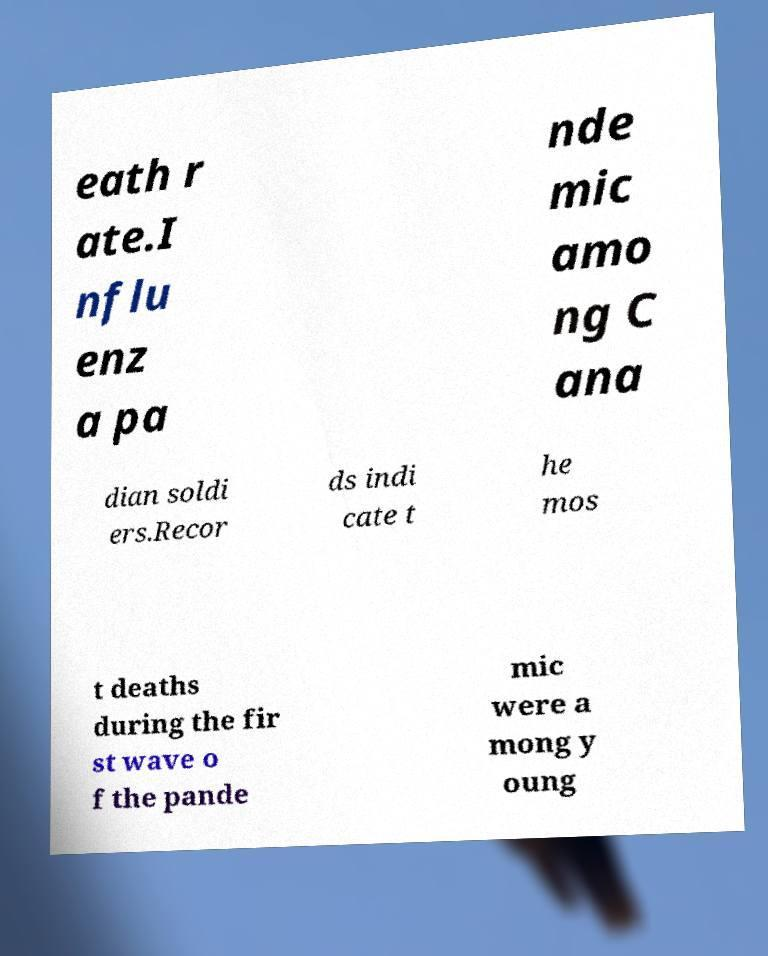What messages or text are displayed in this image? I need them in a readable, typed format. eath r ate.I nflu enz a pa nde mic amo ng C ana dian soldi ers.Recor ds indi cate t he mos t deaths during the fir st wave o f the pande mic were a mong y oung 